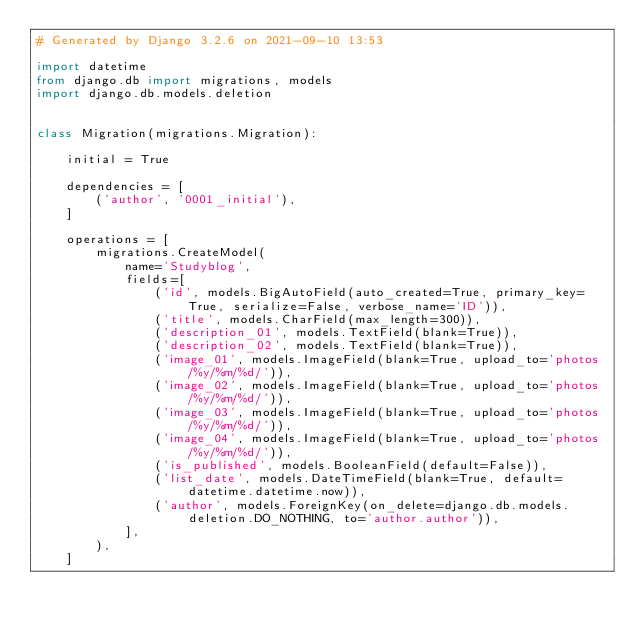Convert code to text. <code><loc_0><loc_0><loc_500><loc_500><_Python_># Generated by Django 3.2.6 on 2021-09-10 13:53

import datetime
from django.db import migrations, models
import django.db.models.deletion


class Migration(migrations.Migration):

    initial = True

    dependencies = [
        ('author', '0001_initial'),
    ]

    operations = [
        migrations.CreateModel(
            name='Studyblog',
            fields=[
                ('id', models.BigAutoField(auto_created=True, primary_key=True, serialize=False, verbose_name='ID')),
                ('title', models.CharField(max_length=300)),
                ('description_01', models.TextField(blank=True)),
                ('description_02', models.TextField(blank=True)),
                ('image_01', models.ImageField(blank=True, upload_to='photos/%y/%m/%d/')),
                ('image_02', models.ImageField(blank=True, upload_to='photos/%y/%m/%d/')),
                ('image_03', models.ImageField(blank=True, upload_to='photos/%y/%m/%d/')),
                ('image_04', models.ImageField(blank=True, upload_to='photos/%y/%m/%d/')),
                ('is_published', models.BooleanField(default=False)),
                ('list_date', models.DateTimeField(blank=True, default=datetime.datetime.now)),
                ('author', models.ForeignKey(on_delete=django.db.models.deletion.DO_NOTHING, to='author.author')),
            ],
        ),
    ]
</code> 